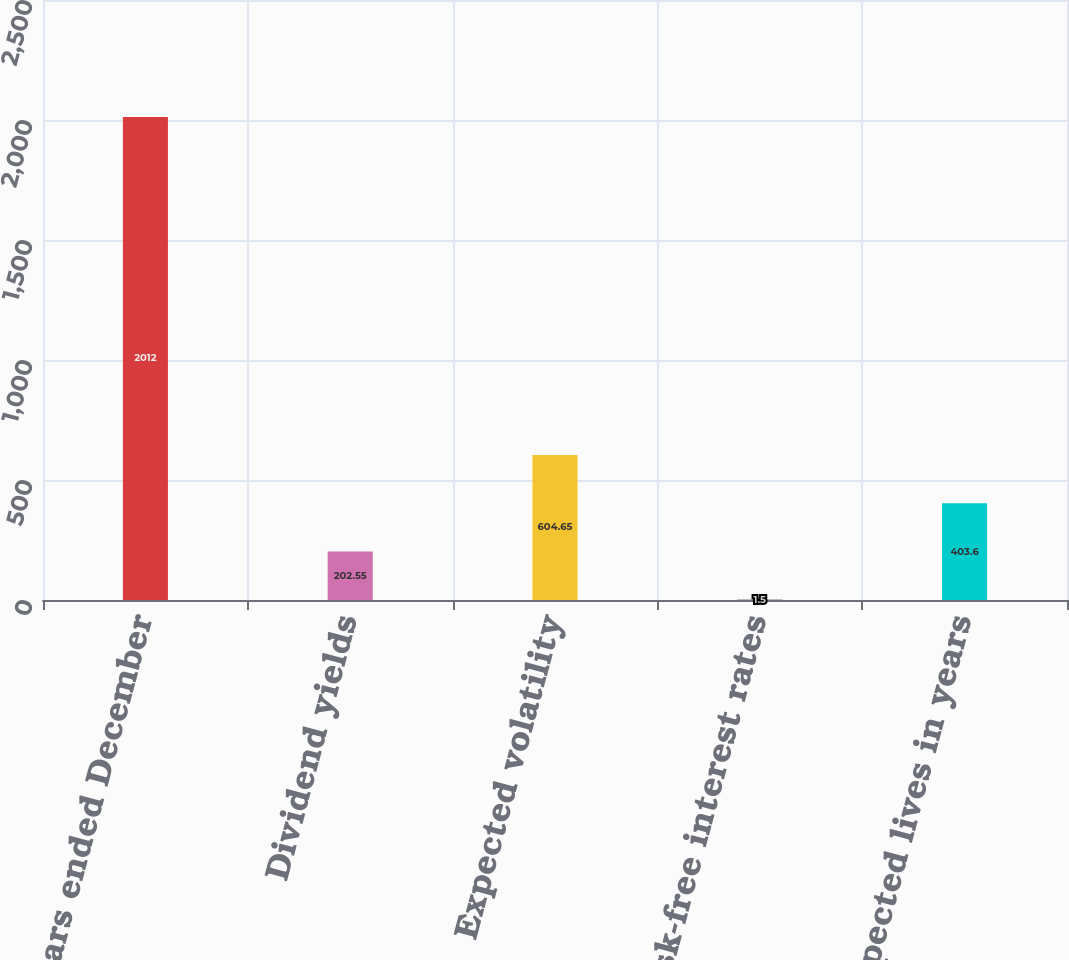Convert chart. <chart><loc_0><loc_0><loc_500><loc_500><bar_chart><fcel>For the years ended December<fcel>Dividend yields<fcel>Expected volatility<fcel>Risk-free interest rates<fcel>Expected lives in years<nl><fcel>2012<fcel>202.55<fcel>604.65<fcel>1.5<fcel>403.6<nl></chart> 